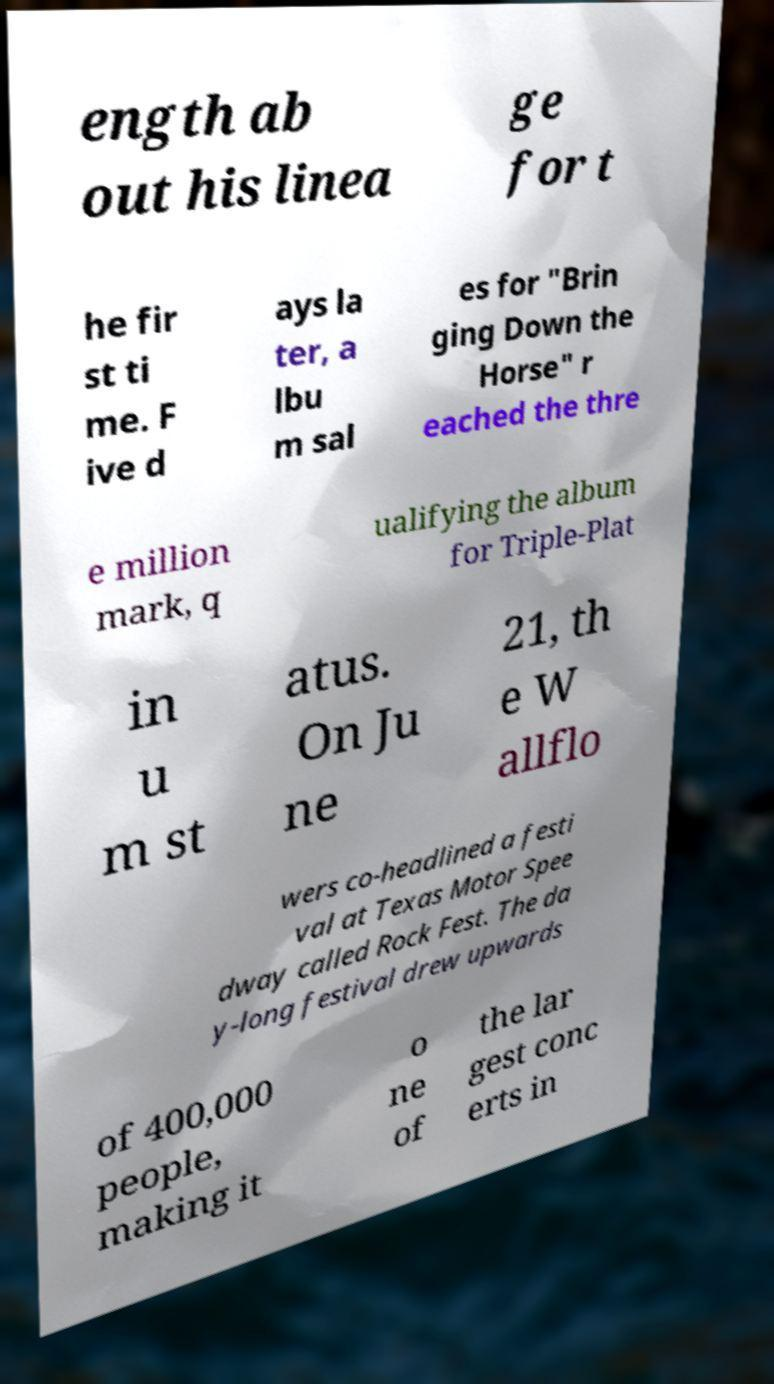Please identify and transcribe the text found in this image. ength ab out his linea ge for t he fir st ti me. F ive d ays la ter, a lbu m sal es for "Brin ging Down the Horse" r eached the thre e million mark, q ualifying the album for Triple-Plat in u m st atus. On Ju ne 21, th e W allflo wers co-headlined a festi val at Texas Motor Spee dway called Rock Fest. The da y-long festival drew upwards of 400,000 people, making it o ne of the lar gest conc erts in 